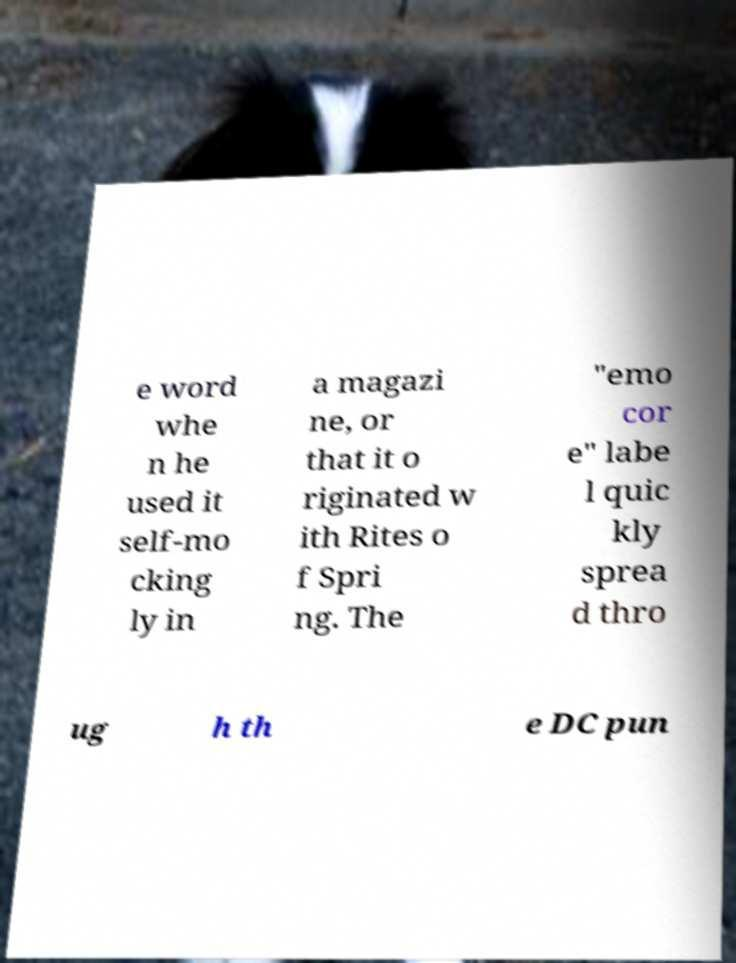Could you assist in decoding the text presented in this image and type it out clearly? e word whe n he used it self-mo cking ly in a magazi ne, or that it o riginated w ith Rites o f Spri ng. The "emo cor e" labe l quic kly sprea d thro ug h th e DC pun 